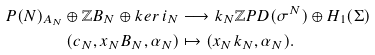Convert formula to latex. <formula><loc_0><loc_0><loc_500><loc_500>P ( N ) _ { A _ { N } } \oplus \mathbb { Z } B _ { N } \oplus k e r \, i _ { N } & \longrightarrow k _ { N } \mathbb { Z } P D ( \sigma ^ { N } ) \oplus H _ { 1 } ( \Sigma ) \\ ( c _ { N } , x _ { N } B _ { N } , \alpha _ { N } ) & \mapsto ( x _ { N } k _ { N } , \alpha _ { N } ) .</formula> 